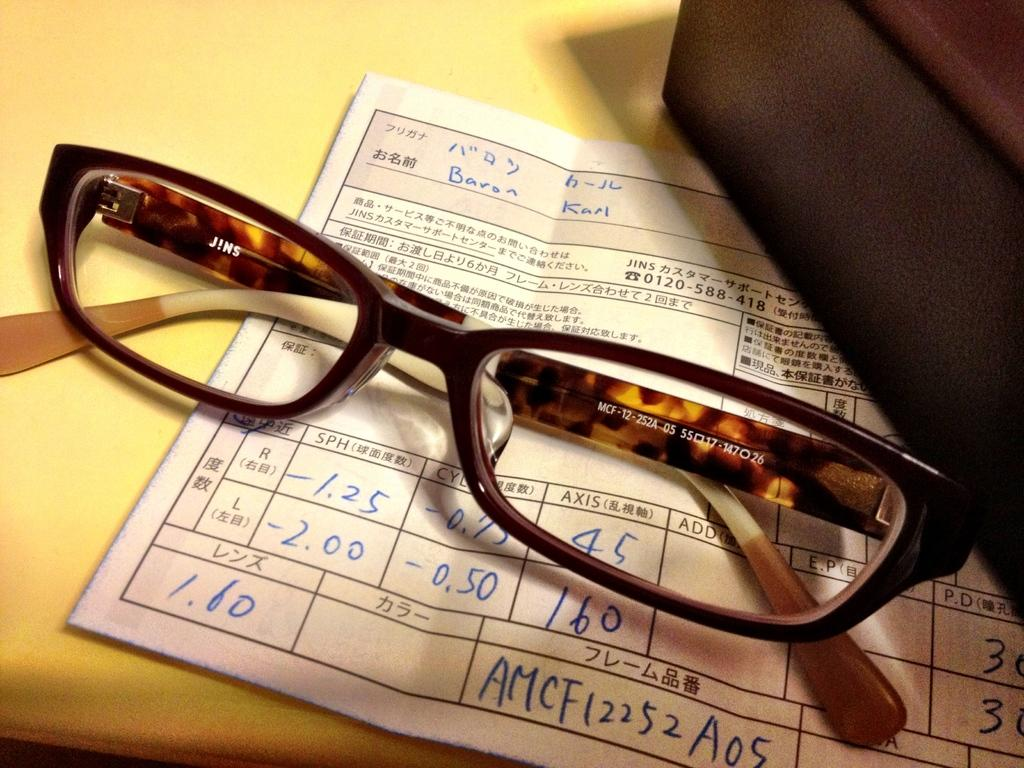What is present on the paper in the image? There are specs placed on a paper in the image. Where is the paper located? The paper is on a table in the image. What else can be seen on the right side of the image? There is a black box on the right side of the image. What color is the hair on the paper in the image? There is no hair present on the paper in the image. 